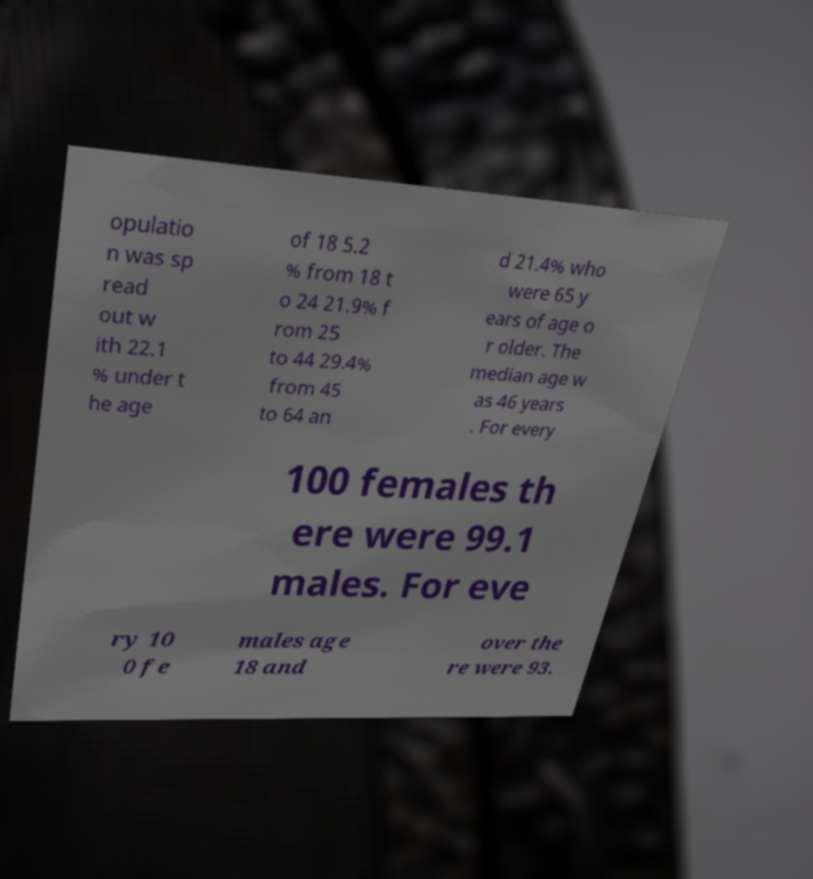I need the written content from this picture converted into text. Can you do that? opulatio n was sp read out w ith 22.1 % under t he age of 18 5.2 % from 18 t o 24 21.9% f rom 25 to 44 29.4% from 45 to 64 an d 21.4% who were 65 y ears of age o r older. The median age w as 46 years . For every 100 females th ere were 99.1 males. For eve ry 10 0 fe males age 18 and over the re were 93. 